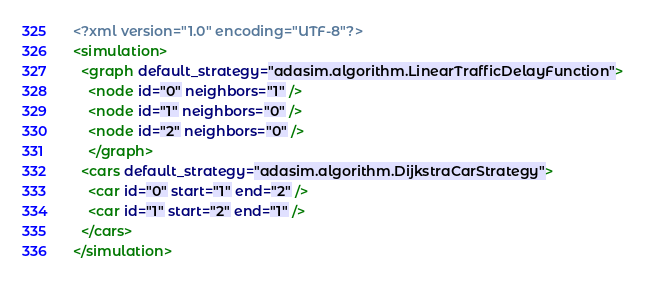<code> <loc_0><loc_0><loc_500><loc_500><_XML_><?xml version="1.0" encoding="UTF-8"?>
<simulation>
  <graph default_strategy="adasim.algorithm.LinearTrafficDelayFunction">
    <node id="0" neighbors="1" />
    <node id="1" neighbors="0" />
    <node id="2" neighbors="0" />
    </graph>
  <cars default_strategy="adasim.algorithm.DijkstraCarStrategy">
    <car id="0" start="1" end="2" />
    <car id="1" start="2" end="1" />
  </cars>
</simulation></code> 